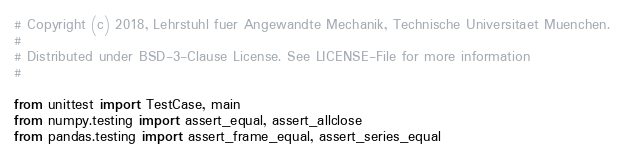Convert code to text. <code><loc_0><loc_0><loc_500><loc_500><_Python_># Copyright (c) 2018, Lehrstuhl fuer Angewandte Mechanik, Technische Universitaet Muenchen.
#
# Distributed under BSD-3-Clause License. See LICENSE-File for more information
#

from unittest import TestCase, main
from numpy.testing import assert_equal, assert_allclose
from pandas.testing import assert_frame_equal, assert_series_equal</code> 